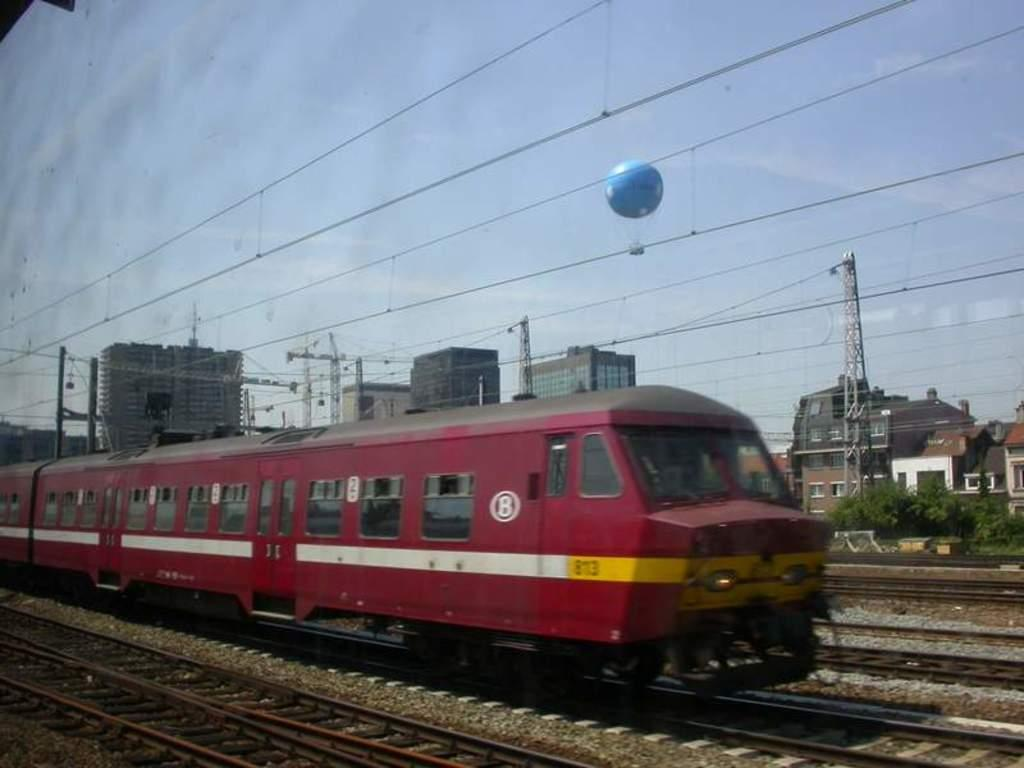What is the main subject of the image? There is a train in the image. What is the train traveling on? There are railway tracks in the image. What can be seen in the background of the image? There are buildings and trees visible in the image. What structures are present near the railway tracks? Antennas are visible in the image. What is happening in the sky in the image? A parachute is flying in the sky in the image. Where is the basin located in the image? There is no basin present in the image. What type of hook is attached to the train in the image? There are no hooks attached to the train in the image. 